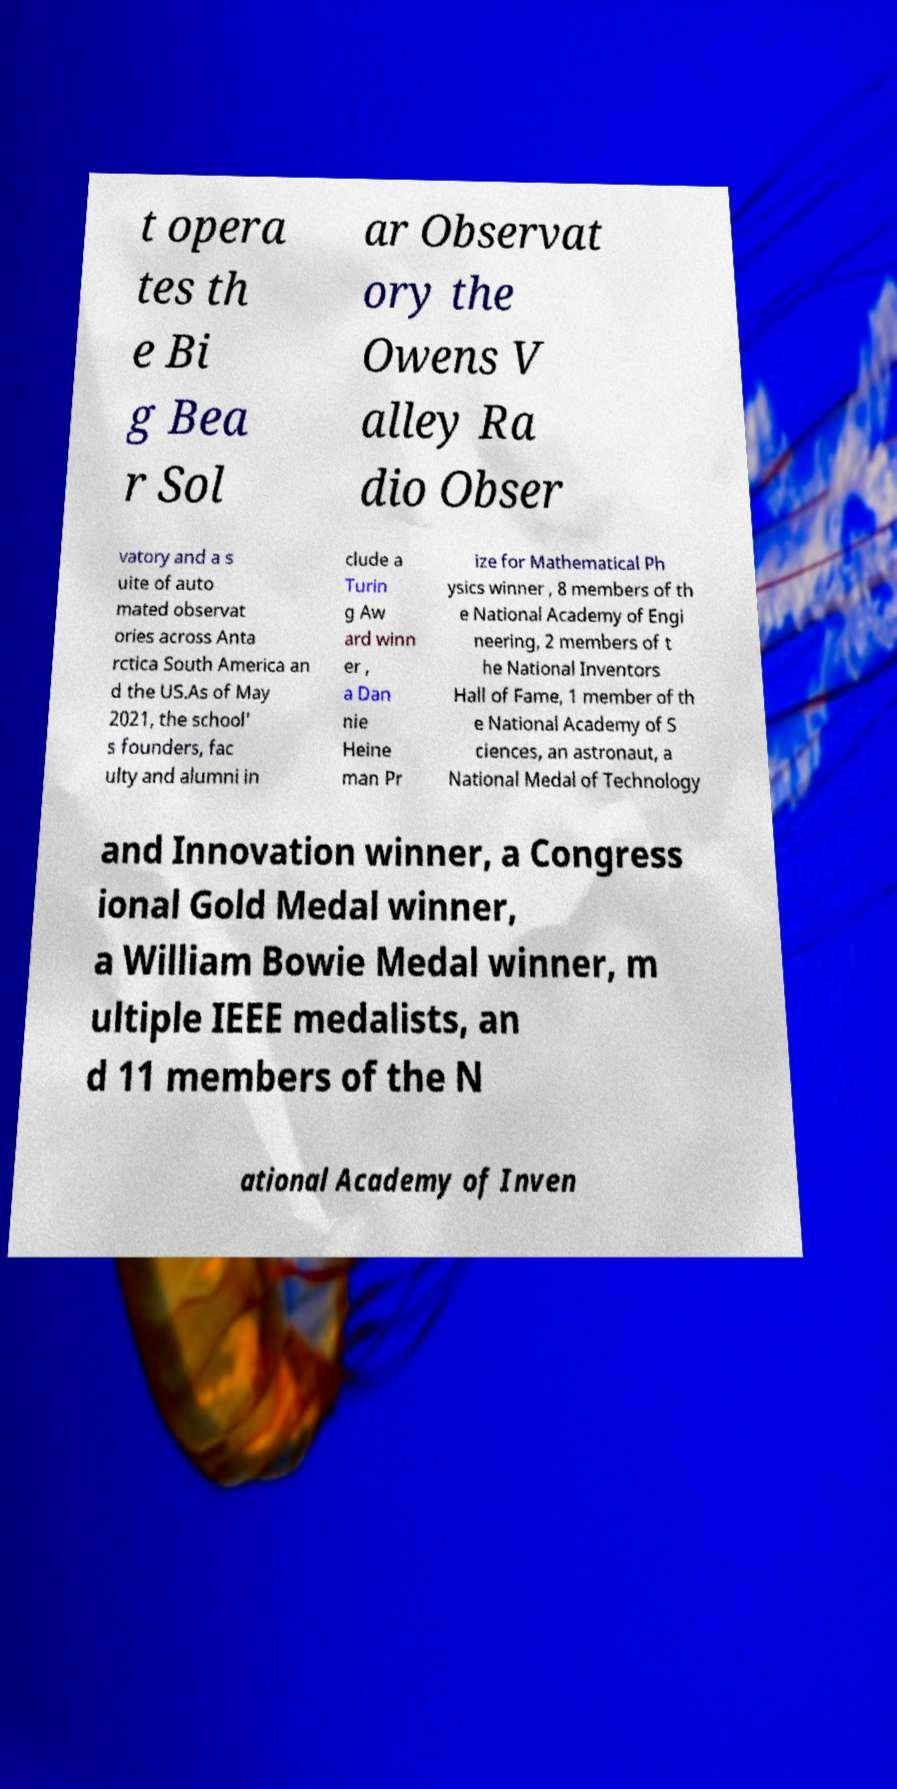Can you read and provide the text displayed in the image?This photo seems to have some interesting text. Can you extract and type it out for me? t opera tes th e Bi g Bea r Sol ar Observat ory the Owens V alley Ra dio Obser vatory and a s uite of auto mated observat ories across Anta rctica South America an d the US.As of May 2021, the school' s founders, fac ulty and alumni in clude a Turin g Aw ard winn er , a Dan nie Heine man Pr ize for Mathematical Ph ysics winner , 8 members of th e National Academy of Engi neering, 2 members of t he National Inventors Hall of Fame, 1 member of th e National Academy of S ciences, an astronaut, a National Medal of Technology and Innovation winner, a Congress ional Gold Medal winner, a William Bowie Medal winner, m ultiple IEEE medalists, an d 11 members of the N ational Academy of Inven 